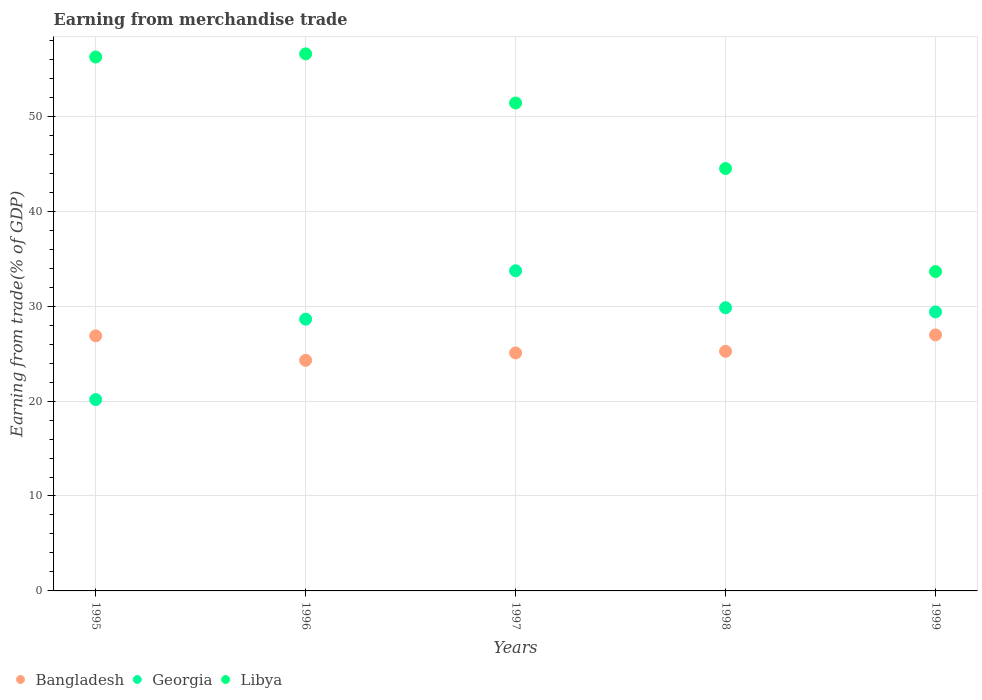How many different coloured dotlines are there?
Your answer should be compact. 3. Is the number of dotlines equal to the number of legend labels?
Keep it short and to the point. Yes. What is the earnings from trade in Bangladesh in 1999?
Make the answer very short. 26.97. Across all years, what is the maximum earnings from trade in Bangladesh?
Make the answer very short. 26.97. Across all years, what is the minimum earnings from trade in Georgia?
Ensure brevity in your answer.  20.16. In which year was the earnings from trade in Bangladesh maximum?
Offer a terse response. 1999. In which year was the earnings from trade in Georgia minimum?
Offer a terse response. 1995. What is the total earnings from trade in Georgia in the graph?
Provide a short and direct response. 141.74. What is the difference between the earnings from trade in Libya in 1996 and that in 1999?
Give a very brief answer. 22.93. What is the difference between the earnings from trade in Georgia in 1995 and the earnings from trade in Bangladesh in 1996?
Your answer should be compact. -4.13. What is the average earnings from trade in Libya per year?
Offer a terse response. 48.47. In the year 1995, what is the difference between the earnings from trade in Georgia and earnings from trade in Bangladesh?
Offer a very short reply. -6.71. What is the ratio of the earnings from trade in Georgia in 1997 to that in 1999?
Give a very brief answer. 1.15. What is the difference between the highest and the second highest earnings from trade in Bangladesh?
Keep it short and to the point. 0.1. What is the difference between the highest and the lowest earnings from trade in Bangladesh?
Make the answer very short. 2.68. Is the sum of the earnings from trade in Georgia in 1995 and 1996 greater than the maximum earnings from trade in Bangladesh across all years?
Your response must be concise. Yes. Is the earnings from trade in Libya strictly greater than the earnings from trade in Bangladesh over the years?
Offer a very short reply. Yes. How many years are there in the graph?
Your response must be concise. 5. Does the graph contain any zero values?
Your response must be concise. No. Does the graph contain grids?
Give a very brief answer. Yes. Where does the legend appear in the graph?
Provide a short and direct response. Bottom left. What is the title of the graph?
Make the answer very short. Earning from merchandise trade. What is the label or title of the X-axis?
Your response must be concise. Years. What is the label or title of the Y-axis?
Give a very brief answer. Earning from trade(% of GDP). What is the Earning from trade(% of GDP) of Bangladesh in 1995?
Keep it short and to the point. 26.87. What is the Earning from trade(% of GDP) in Georgia in 1995?
Give a very brief answer. 20.16. What is the Earning from trade(% of GDP) of Libya in 1995?
Ensure brevity in your answer.  56.24. What is the Earning from trade(% of GDP) of Bangladesh in 1996?
Ensure brevity in your answer.  24.29. What is the Earning from trade(% of GDP) of Georgia in 1996?
Keep it short and to the point. 28.63. What is the Earning from trade(% of GDP) of Libya in 1996?
Offer a very short reply. 56.58. What is the Earning from trade(% of GDP) of Bangladesh in 1997?
Your answer should be compact. 25.07. What is the Earning from trade(% of GDP) in Georgia in 1997?
Your answer should be very brief. 33.73. What is the Earning from trade(% of GDP) of Libya in 1997?
Your answer should be compact. 51.4. What is the Earning from trade(% of GDP) of Bangladesh in 1998?
Ensure brevity in your answer.  25.24. What is the Earning from trade(% of GDP) in Georgia in 1998?
Give a very brief answer. 29.83. What is the Earning from trade(% of GDP) in Libya in 1998?
Make the answer very short. 44.5. What is the Earning from trade(% of GDP) in Bangladesh in 1999?
Make the answer very short. 26.97. What is the Earning from trade(% of GDP) in Georgia in 1999?
Offer a very short reply. 29.39. What is the Earning from trade(% of GDP) of Libya in 1999?
Give a very brief answer. 33.65. Across all years, what is the maximum Earning from trade(% of GDP) in Bangladesh?
Provide a succinct answer. 26.97. Across all years, what is the maximum Earning from trade(% of GDP) of Georgia?
Offer a very short reply. 33.73. Across all years, what is the maximum Earning from trade(% of GDP) of Libya?
Offer a terse response. 56.58. Across all years, what is the minimum Earning from trade(% of GDP) in Bangladesh?
Provide a short and direct response. 24.29. Across all years, what is the minimum Earning from trade(% of GDP) of Georgia?
Ensure brevity in your answer.  20.16. Across all years, what is the minimum Earning from trade(% of GDP) of Libya?
Provide a short and direct response. 33.65. What is the total Earning from trade(% of GDP) of Bangladesh in the graph?
Offer a very short reply. 128.44. What is the total Earning from trade(% of GDP) of Georgia in the graph?
Offer a very short reply. 141.74. What is the total Earning from trade(% of GDP) of Libya in the graph?
Your response must be concise. 242.36. What is the difference between the Earning from trade(% of GDP) of Bangladesh in 1995 and that in 1996?
Ensure brevity in your answer.  2.58. What is the difference between the Earning from trade(% of GDP) in Georgia in 1995 and that in 1996?
Your answer should be very brief. -8.47. What is the difference between the Earning from trade(% of GDP) of Libya in 1995 and that in 1996?
Provide a short and direct response. -0.33. What is the difference between the Earning from trade(% of GDP) of Bangladesh in 1995 and that in 1997?
Give a very brief answer. 1.8. What is the difference between the Earning from trade(% of GDP) of Georgia in 1995 and that in 1997?
Give a very brief answer. -13.57. What is the difference between the Earning from trade(% of GDP) of Libya in 1995 and that in 1997?
Keep it short and to the point. 4.84. What is the difference between the Earning from trade(% of GDP) in Bangladesh in 1995 and that in 1998?
Your answer should be compact. 1.63. What is the difference between the Earning from trade(% of GDP) of Georgia in 1995 and that in 1998?
Ensure brevity in your answer.  -9.67. What is the difference between the Earning from trade(% of GDP) in Libya in 1995 and that in 1998?
Offer a very short reply. 11.75. What is the difference between the Earning from trade(% of GDP) in Bangladesh in 1995 and that in 1999?
Offer a very short reply. -0.1. What is the difference between the Earning from trade(% of GDP) in Georgia in 1995 and that in 1999?
Make the answer very short. -9.23. What is the difference between the Earning from trade(% of GDP) of Libya in 1995 and that in 1999?
Provide a short and direct response. 22.6. What is the difference between the Earning from trade(% of GDP) in Bangladesh in 1996 and that in 1997?
Give a very brief answer. -0.78. What is the difference between the Earning from trade(% of GDP) in Georgia in 1996 and that in 1997?
Your response must be concise. -5.1. What is the difference between the Earning from trade(% of GDP) of Libya in 1996 and that in 1997?
Make the answer very short. 5.18. What is the difference between the Earning from trade(% of GDP) in Bangladesh in 1996 and that in 1998?
Provide a succinct answer. -0.95. What is the difference between the Earning from trade(% of GDP) in Georgia in 1996 and that in 1998?
Keep it short and to the point. -1.21. What is the difference between the Earning from trade(% of GDP) of Libya in 1996 and that in 1998?
Make the answer very short. 12.08. What is the difference between the Earning from trade(% of GDP) in Bangladesh in 1996 and that in 1999?
Your answer should be compact. -2.68. What is the difference between the Earning from trade(% of GDP) in Georgia in 1996 and that in 1999?
Provide a succinct answer. -0.77. What is the difference between the Earning from trade(% of GDP) of Libya in 1996 and that in 1999?
Ensure brevity in your answer.  22.93. What is the difference between the Earning from trade(% of GDP) in Bangladesh in 1997 and that in 1998?
Provide a succinct answer. -0.17. What is the difference between the Earning from trade(% of GDP) of Georgia in 1997 and that in 1998?
Provide a succinct answer. 3.89. What is the difference between the Earning from trade(% of GDP) in Libya in 1997 and that in 1998?
Provide a succinct answer. 6.9. What is the difference between the Earning from trade(% of GDP) of Bangladesh in 1997 and that in 1999?
Provide a short and direct response. -1.9. What is the difference between the Earning from trade(% of GDP) in Georgia in 1997 and that in 1999?
Offer a terse response. 4.33. What is the difference between the Earning from trade(% of GDP) in Libya in 1997 and that in 1999?
Your answer should be compact. 17.75. What is the difference between the Earning from trade(% of GDP) in Bangladesh in 1998 and that in 1999?
Your answer should be very brief. -1.73. What is the difference between the Earning from trade(% of GDP) in Georgia in 1998 and that in 1999?
Provide a succinct answer. 0.44. What is the difference between the Earning from trade(% of GDP) in Libya in 1998 and that in 1999?
Ensure brevity in your answer.  10.85. What is the difference between the Earning from trade(% of GDP) of Bangladesh in 1995 and the Earning from trade(% of GDP) of Georgia in 1996?
Give a very brief answer. -1.76. What is the difference between the Earning from trade(% of GDP) of Bangladesh in 1995 and the Earning from trade(% of GDP) of Libya in 1996?
Make the answer very short. -29.7. What is the difference between the Earning from trade(% of GDP) in Georgia in 1995 and the Earning from trade(% of GDP) in Libya in 1996?
Make the answer very short. -36.42. What is the difference between the Earning from trade(% of GDP) in Bangladesh in 1995 and the Earning from trade(% of GDP) in Georgia in 1997?
Your answer should be compact. -6.86. What is the difference between the Earning from trade(% of GDP) of Bangladesh in 1995 and the Earning from trade(% of GDP) of Libya in 1997?
Keep it short and to the point. -24.53. What is the difference between the Earning from trade(% of GDP) in Georgia in 1995 and the Earning from trade(% of GDP) in Libya in 1997?
Provide a short and direct response. -31.24. What is the difference between the Earning from trade(% of GDP) of Bangladesh in 1995 and the Earning from trade(% of GDP) of Georgia in 1998?
Keep it short and to the point. -2.96. What is the difference between the Earning from trade(% of GDP) of Bangladesh in 1995 and the Earning from trade(% of GDP) of Libya in 1998?
Keep it short and to the point. -17.62. What is the difference between the Earning from trade(% of GDP) of Georgia in 1995 and the Earning from trade(% of GDP) of Libya in 1998?
Your response must be concise. -24.34. What is the difference between the Earning from trade(% of GDP) of Bangladesh in 1995 and the Earning from trade(% of GDP) of Georgia in 1999?
Keep it short and to the point. -2.52. What is the difference between the Earning from trade(% of GDP) of Bangladesh in 1995 and the Earning from trade(% of GDP) of Libya in 1999?
Offer a very short reply. -6.78. What is the difference between the Earning from trade(% of GDP) in Georgia in 1995 and the Earning from trade(% of GDP) in Libya in 1999?
Make the answer very short. -13.49. What is the difference between the Earning from trade(% of GDP) of Bangladesh in 1996 and the Earning from trade(% of GDP) of Georgia in 1997?
Your answer should be very brief. -9.43. What is the difference between the Earning from trade(% of GDP) in Bangladesh in 1996 and the Earning from trade(% of GDP) in Libya in 1997?
Keep it short and to the point. -27.11. What is the difference between the Earning from trade(% of GDP) in Georgia in 1996 and the Earning from trade(% of GDP) in Libya in 1997?
Ensure brevity in your answer.  -22.77. What is the difference between the Earning from trade(% of GDP) in Bangladesh in 1996 and the Earning from trade(% of GDP) in Georgia in 1998?
Ensure brevity in your answer.  -5.54. What is the difference between the Earning from trade(% of GDP) of Bangladesh in 1996 and the Earning from trade(% of GDP) of Libya in 1998?
Your response must be concise. -20.2. What is the difference between the Earning from trade(% of GDP) in Georgia in 1996 and the Earning from trade(% of GDP) in Libya in 1998?
Make the answer very short. -15.87. What is the difference between the Earning from trade(% of GDP) in Bangladesh in 1996 and the Earning from trade(% of GDP) in Georgia in 1999?
Provide a short and direct response. -5.1. What is the difference between the Earning from trade(% of GDP) in Bangladesh in 1996 and the Earning from trade(% of GDP) in Libya in 1999?
Your answer should be compact. -9.35. What is the difference between the Earning from trade(% of GDP) of Georgia in 1996 and the Earning from trade(% of GDP) of Libya in 1999?
Your answer should be compact. -5.02. What is the difference between the Earning from trade(% of GDP) in Bangladesh in 1997 and the Earning from trade(% of GDP) in Georgia in 1998?
Keep it short and to the point. -4.76. What is the difference between the Earning from trade(% of GDP) in Bangladesh in 1997 and the Earning from trade(% of GDP) in Libya in 1998?
Keep it short and to the point. -19.43. What is the difference between the Earning from trade(% of GDP) in Georgia in 1997 and the Earning from trade(% of GDP) in Libya in 1998?
Your answer should be very brief. -10.77. What is the difference between the Earning from trade(% of GDP) of Bangladesh in 1997 and the Earning from trade(% of GDP) of Georgia in 1999?
Offer a very short reply. -4.32. What is the difference between the Earning from trade(% of GDP) of Bangladesh in 1997 and the Earning from trade(% of GDP) of Libya in 1999?
Your response must be concise. -8.58. What is the difference between the Earning from trade(% of GDP) of Georgia in 1997 and the Earning from trade(% of GDP) of Libya in 1999?
Your answer should be very brief. 0.08. What is the difference between the Earning from trade(% of GDP) of Bangladesh in 1998 and the Earning from trade(% of GDP) of Georgia in 1999?
Keep it short and to the point. -4.15. What is the difference between the Earning from trade(% of GDP) in Bangladesh in 1998 and the Earning from trade(% of GDP) in Libya in 1999?
Ensure brevity in your answer.  -8.41. What is the difference between the Earning from trade(% of GDP) of Georgia in 1998 and the Earning from trade(% of GDP) of Libya in 1999?
Give a very brief answer. -3.81. What is the average Earning from trade(% of GDP) in Bangladesh per year?
Provide a succinct answer. 25.69. What is the average Earning from trade(% of GDP) in Georgia per year?
Provide a short and direct response. 28.35. What is the average Earning from trade(% of GDP) in Libya per year?
Make the answer very short. 48.47. In the year 1995, what is the difference between the Earning from trade(% of GDP) in Bangladesh and Earning from trade(% of GDP) in Georgia?
Offer a terse response. 6.71. In the year 1995, what is the difference between the Earning from trade(% of GDP) of Bangladesh and Earning from trade(% of GDP) of Libya?
Offer a very short reply. -29.37. In the year 1995, what is the difference between the Earning from trade(% of GDP) of Georgia and Earning from trade(% of GDP) of Libya?
Your answer should be compact. -36.09. In the year 1996, what is the difference between the Earning from trade(% of GDP) in Bangladesh and Earning from trade(% of GDP) in Georgia?
Keep it short and to the point. -4.34. In the year 1996, what is the difference between the Earning from trade(% of GDP) of Bangladesh and Earning from trade(% of GDP) of Libya?
Ensure brevity in your answer.  -32.28. In the year 1996, what is the difference between the Earning from trade(% of GDP) in Georgia and Earning from trade(% of GDP) in Libya?
Your answer should be compact. -27.95. In the year 1997, what is the difference between the Earning from trade(% of GDP) in Bangladesh and Earning from trade(% of GDP) in Georgia?
Offer a terse response. -8.66. In the year 1997, what is the difference between the Earning from trade(% of GDP) of Bangladesh and Earning from trade(% of GDP) of Libya?
Offer a terse response. -26.33. In the year 1997, what is the difference between the Earning from trade(% of GDP) in Georgia and Earning from trade(% of GDP) in Libya?
Provide a succinct answer. -17.67. In the year 1998, what is the difference between the Earning from trade(% of GDP) in Bangladesh and Earning from trade(% of GDP) in Georgia?
Ensure brevity in your answer.  -4.59. In the year 1998, what is the difference between the Earning from trade(% of GDP) in Bangladesh and Earning from trade(% of GDP) in Libya?
Keep it short and to the point. -19.26. In the year 1998, what is the difference between the Earning from trade(% of GDP) of Georgia and Earning from trade(% of GDP) of Libya?
Offer a very short reply. -14.66. In the year 1999, what is the difference between the Earning from trade(% of GDP) in Bangladesh and Earning from trade(% of GDP) in Georgia?
Provide a succinct answer. -2.42. In the year 1999, what is the difference between the Earning from trade(% of GDP) of Bangladesh and Earning from trade(% of GDP) of Libya?
Give a very brief answer. -6.68. In the year 1999, what is the difference between the Earning from trade(% of GDP) of Georgia and Earning from trade(% of GDP) of Libya?
Ensure brevity in your answer.  -4.25. What is the ratio of the Earning from trade(% of GDP) of Bangladesh in 1995 to that in 1996?
Offer a terse response. 1.11. What is the ratio of the Earning from trade(% of GDP) of Georgia in 1995 to that in 1996?
Provide a succinct answer. 0.7. What is the ratio of the Earning from trade(% of GDP) in Bangladesh in 1995 to that in 1997?
Your answer should be very brief. 1.07. What is the ratio of the Earning from trade(% of GDP) in Georgia in 1995 to that in 1997?
Keep it short and to the point. 0.6. What is the ratio of the Earning from trade(% of GDP) in Libya in 1995 to that in 1997?
Make the answer very short. 1.09. What is the ratio of the Earning from trade(% of GDP) in Bangladesh in 1995 to that in 1998?
Keep it short and to the point. 1.06. What is the ratio of the Earning from trade(% of GDP) in Georgia in 1995 to that in 1998?
Offer a very short reply. 0.68. What is the ratio of the Earning from trade(% of GDP) of Libya in 1995 to that in 1998?
Offer a very short reply. 1.26. What is the ratio of the Earning from trade(% of GDP) of Bangladesh in 1995 to that in 1999?
Your answer should be very brief. 1. What is the ratio of the Earning from trade(% of GDP) in Georgia in 1995 to that in 1999?
Ensure brevity in your answer.  0.69. What is the ratio of the Earning from trade(% of GDP) of Libya in 1995 to that in 1999?
Offer a very short reply. 1.67. What is the ratio of the Earning from trade(% of GDP) in Georgia in 1996 to that in 1997?
Provide a short and direct response. 0.85. What is the ratio of the Earning from trade(% of GDP) of Libya in 1996 to that in 1997?
Offer a terse response. 1.1. What is the ratio of the Earning from trade(% of GDP) in Bangladesh in 1996 to that in 1998?
Ensure brevity in your answer.  0.96. What is the ratio of the Earning from trade(% of GDP) in Georgia in 1996 to that in 1998?
Provide a short and direct response. 0.96. What is the ratio of the Earning from trade(% of GDP) of Libya in 1996 to that in 1998?
Provide a succinct answer. 1.27. What is the ratio of the Earning from trade(% of GDP) of Bangladesh in 1996 to that in 1999?
Your answer should be compact. 0.9. What is the ratio of the Earning from trade(% of GDP) in Georgia in 1996 to that in 1999?
Your response must be concise. 0.97. What is the ratio of the Earning from trade(% of GDP) in Libya in 1996 to that in 1999?
Provide a short and direct response. 1.68. What is the ratio of the Earning from trade(% of GDP) of Bangladesh in 1997 to that in 1998?
Ensure brevity in your answer.  0.99. What is the ratio of the Earning from trade(% of GDP) in Georgia in 1997 to that in 1998?
Give a very brief answer. 1.13. What is the ratio of the Earning from trade(% of GDP) in Libya in 1997 to that in 1998?
Provide a short and direct response. 1.16. What is the ratio of the Earning from trade(% of GDP) in Bangladesh in 1997 to that in 1999?
Provide a succinct answer. 0.93. What is the ratio of the Earning from trade(% of GDP) in Georgia in 1997 to that in 1999?
Your answer should be compact. 1.15. What is the ratio of the Earning from trade(% of GDP) in Libya in 1997 to that in 1999?
Provide a succinct answer. 1.53. What is the ratio of the Earning from trade(% of GDP) of Bangladesh in 1998 to that in 1999?
Your answer should be very brief. 0.94. What is the ratio of the Earning from trade(% of GDP) in Libya in 1998 to that in 1999?
Keep it short and to the point. 1.32. What is the difference between the highest and the second highest Earning from trade(% of GDP) in Bangladesh?
Provide a succinct answer. 0.1. What is the difference between the highest and the second highest Earning from trade(% of GDP) in Georgia?
Make the answer very short. 3.89. What is the difference between the highest and the second highest Earning from trade(% of GDP) of Libya?
Offer a very short reply. 0.33. What is the difference between the highest and the lowest Earning from trade(% of GDP) of Bangladesh?
Offer a terse response. 2.68. What is the difference between the highest and the lowest Earning from trade(% of GDP) of Georgia?
Offer a terse response. 13.57. What is the difference between the highest and the lowest Earning from trade(% of GDP) of Libya?
Offer a terse response. 22.93. 